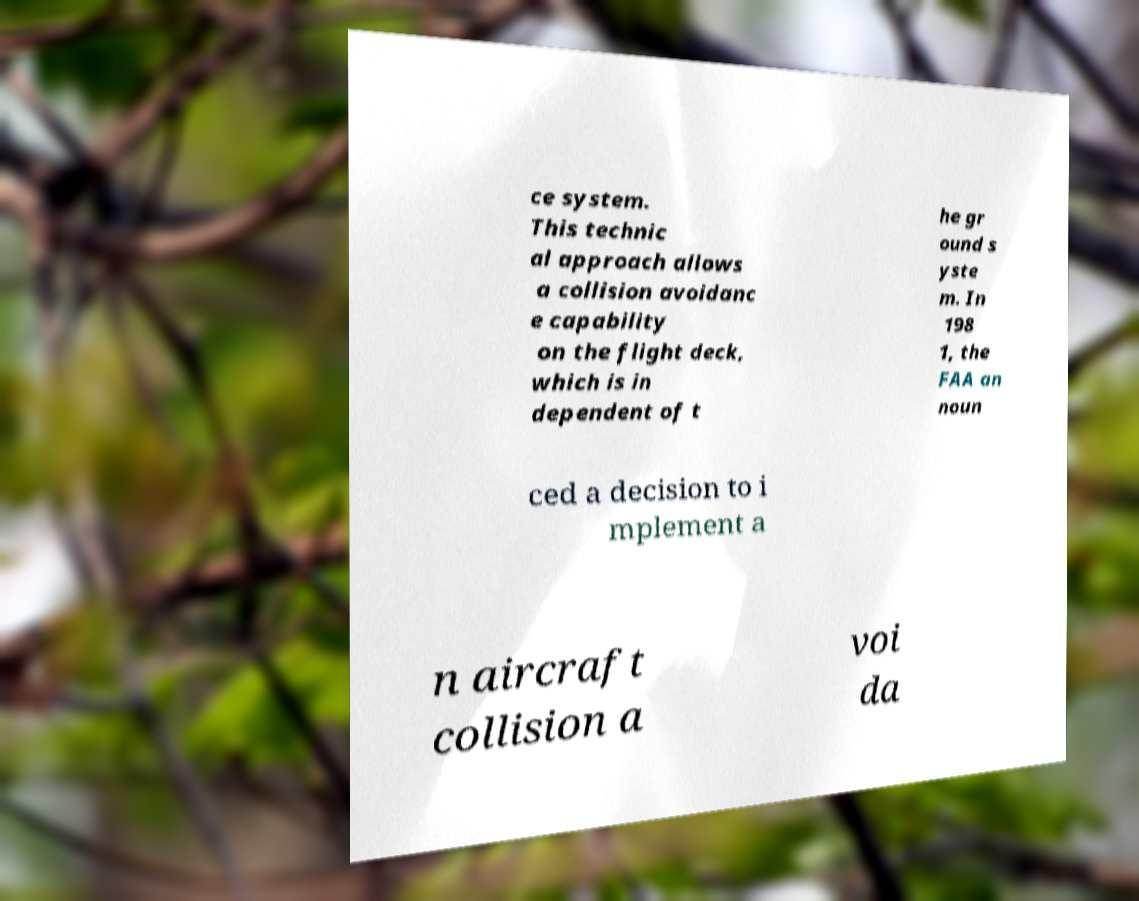Please identify and transcribe the text found in this image. ce system. This technic al approach allows a collision avoidanc e capability on the flight deck, which is in dependent of t he gr ound s yste m. In 198 1, the FAA an noun ced a decision to i mplement a n aircraft collision a voi da 